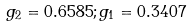<formula> <loc_0><loc_0><loc_500><loc_500>g _ { 2 } = 0 . 6 5 8 5 ; g _ { 1 } = 0 . 3 4 0 7</formula> 